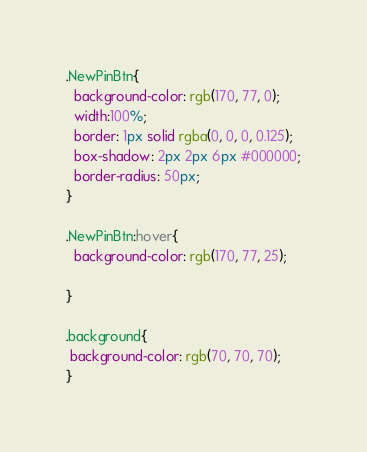<code> <loc_0><loc_0><loc_500><loc_500><_CSS_>.NewPinBtn{
  background-color: rgb(170, 77, 0);
  width:100%;
  border: 1px solid rgba(0, 0, 0, 0.125);
  box-shadow: 2px 2px 6px #000000;
  border-radius: 50px;
}

.NewPinBtn:hover{
  background-color: rgb(170, 77, 25);

}

.background{
 background-color: rgb(70, 70, 70);
}
</code> 